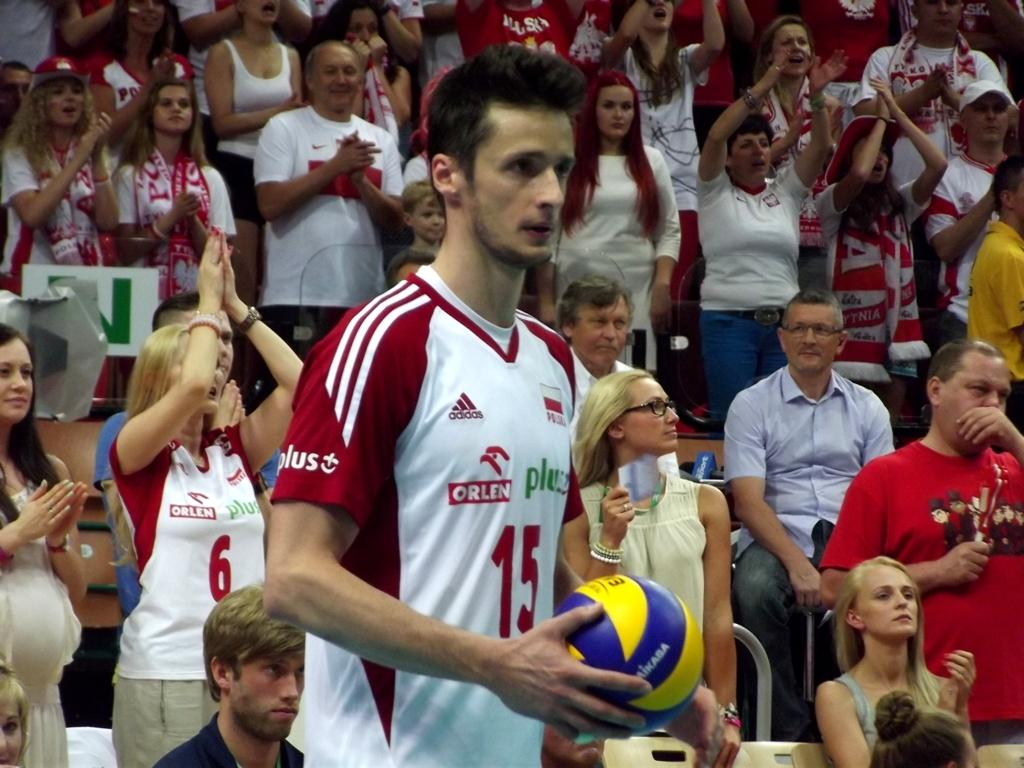What is the man in the image holding? The man is holding a ball in his hands. Can you describe the people in the background of the image? There are people standing and sitting on chairs in the background of the image. What else can be seen in the image besides the man and the people in the background? There are other objects present in the image. What type of sack can be seen hanging from the man's mouth in the image? There is no sack present in the image, nor is there any indication that the man's mouth is involved in any way. 